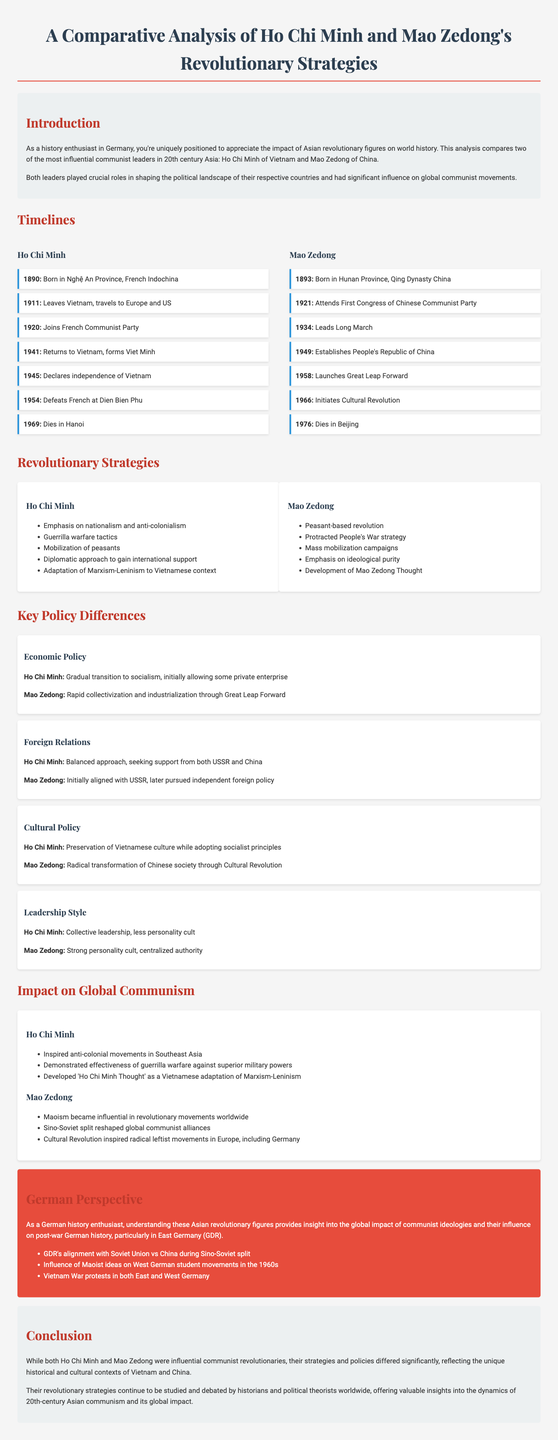what year was Ho Chi Minh born? The document contains a timeline that lists the significant events in Ho Chi Minh's life, including his birth year.
Answer: 1890 what year did Mao Zedong establish the People's Republic of China? The timeline for Mao Zedong includes the year he declared the establishment of the People's Republic of China.
Answer: 1949 what was Ho Chi Minh's approach to economic policy? The key policy differences section outlines Ho Chi Minh’s gradual approach to economic transition, comparing it to Mao Zedong's policy.
Answer: Gradual transition to socialism what strategy did Mao Zedong emphasize? The revolutionary strategies section lists Mao's focus, which was distinctive to his ideology.
Answer: Peasant-based revolution what major event did Ho Chi Minh lead in 1954? The timeline details key events in Ho Chi Minh's life, including his leadership in a significant battle.
Answer: Defeats French at Dien Bien Phu which revolutionary figure initiated the Cultural Revolution? The document's impact section provides insights into the significant policies both leaders implemented, referencing cultural movements.
Answer: Mao Zedong how did Ho Chi Minh's foreign relations approach differ from Mao Zedong's? The key policy differences highlight how each leader approached foreign relations in contrasting ways, particularly in alignment and support.
Answer: Balanced approach what ideology developed from Ho Chi Minh's revolutionary strategies? The impact on global communism section mentions a specific ideological development related to Ho Chi Minh’s influence on communism.
Answer: Ho Chi Minh Thought what was a significant consequence of Mao Zedong's policies? The impact on global communism section provides details on the broader implications of Mao Zedong's actions and policies globally.
Answer: Maoism became influential 